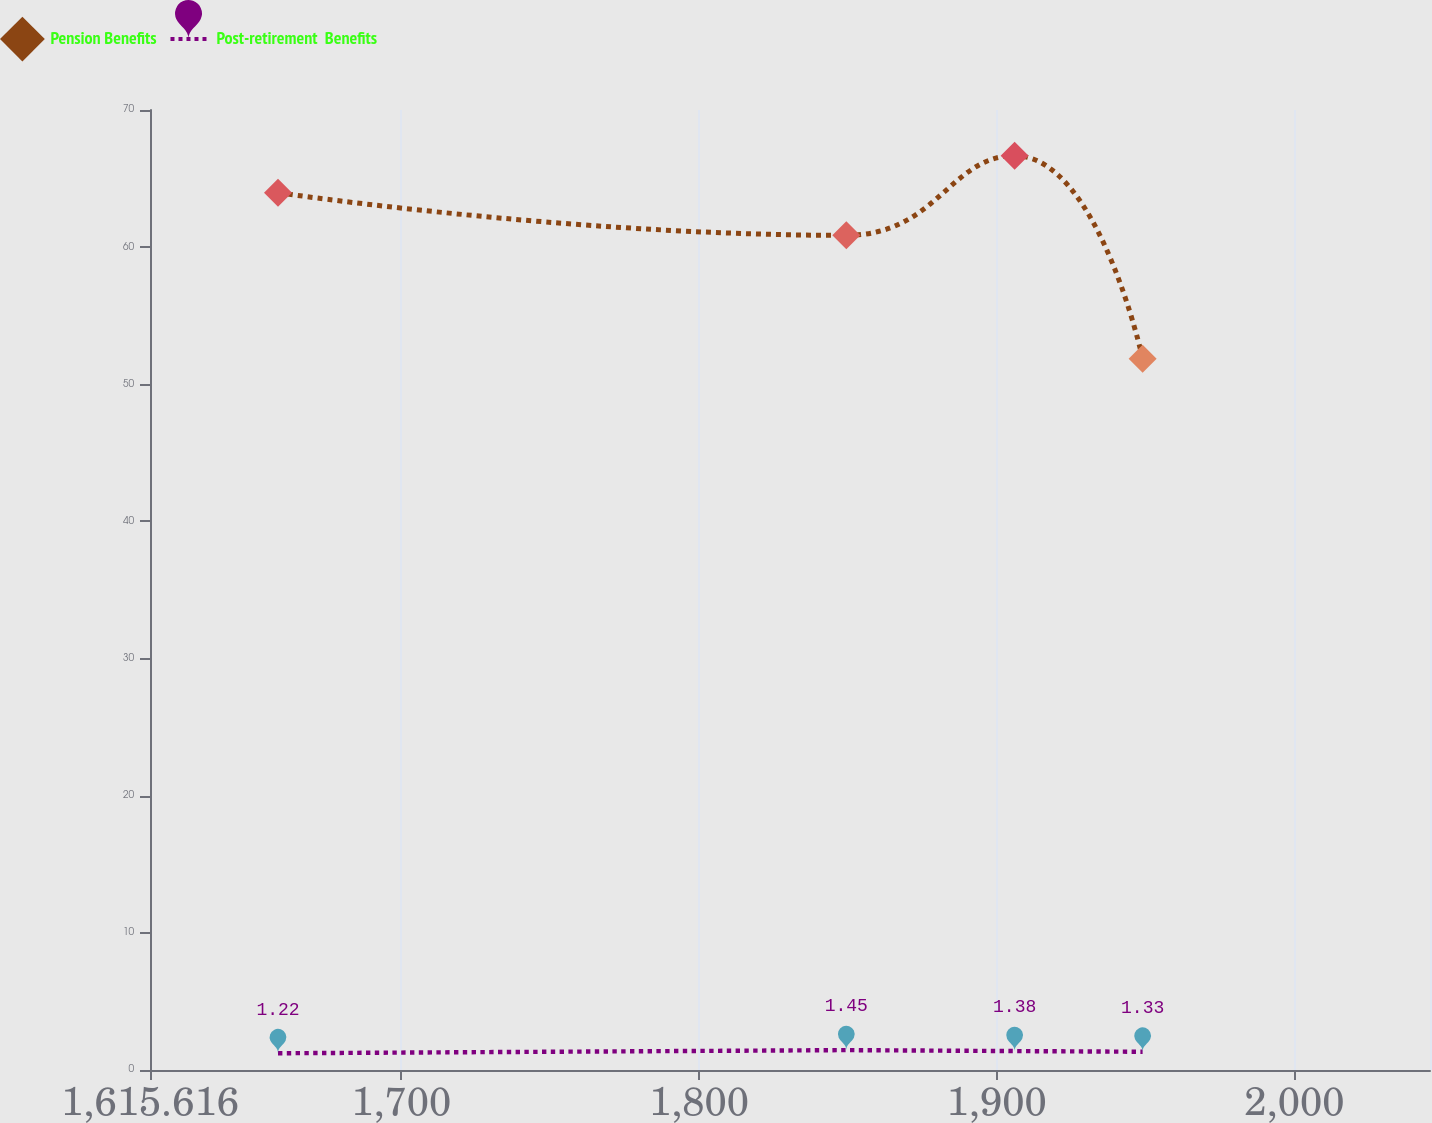Convert chart. <chart><loc_0><loc_0><loc_500><loc_500><line_chart><ecel><fcel>Pension Benefits<fcel>Post-retirement  Benefits<nl><fcel>1658.61<fcel>63.97<fcel>1.22<nl><fcel>1849.5<fcel>60.86<fcel>1.45<nl><fcel>1906.04<fcel>66.67<fcel>1.38<nl><fcel>1949.03<fcel>51.87<fcel>1.33<nl><fcel>2088.55<fcel>65.32<fcel>1.75<nl></chart> 